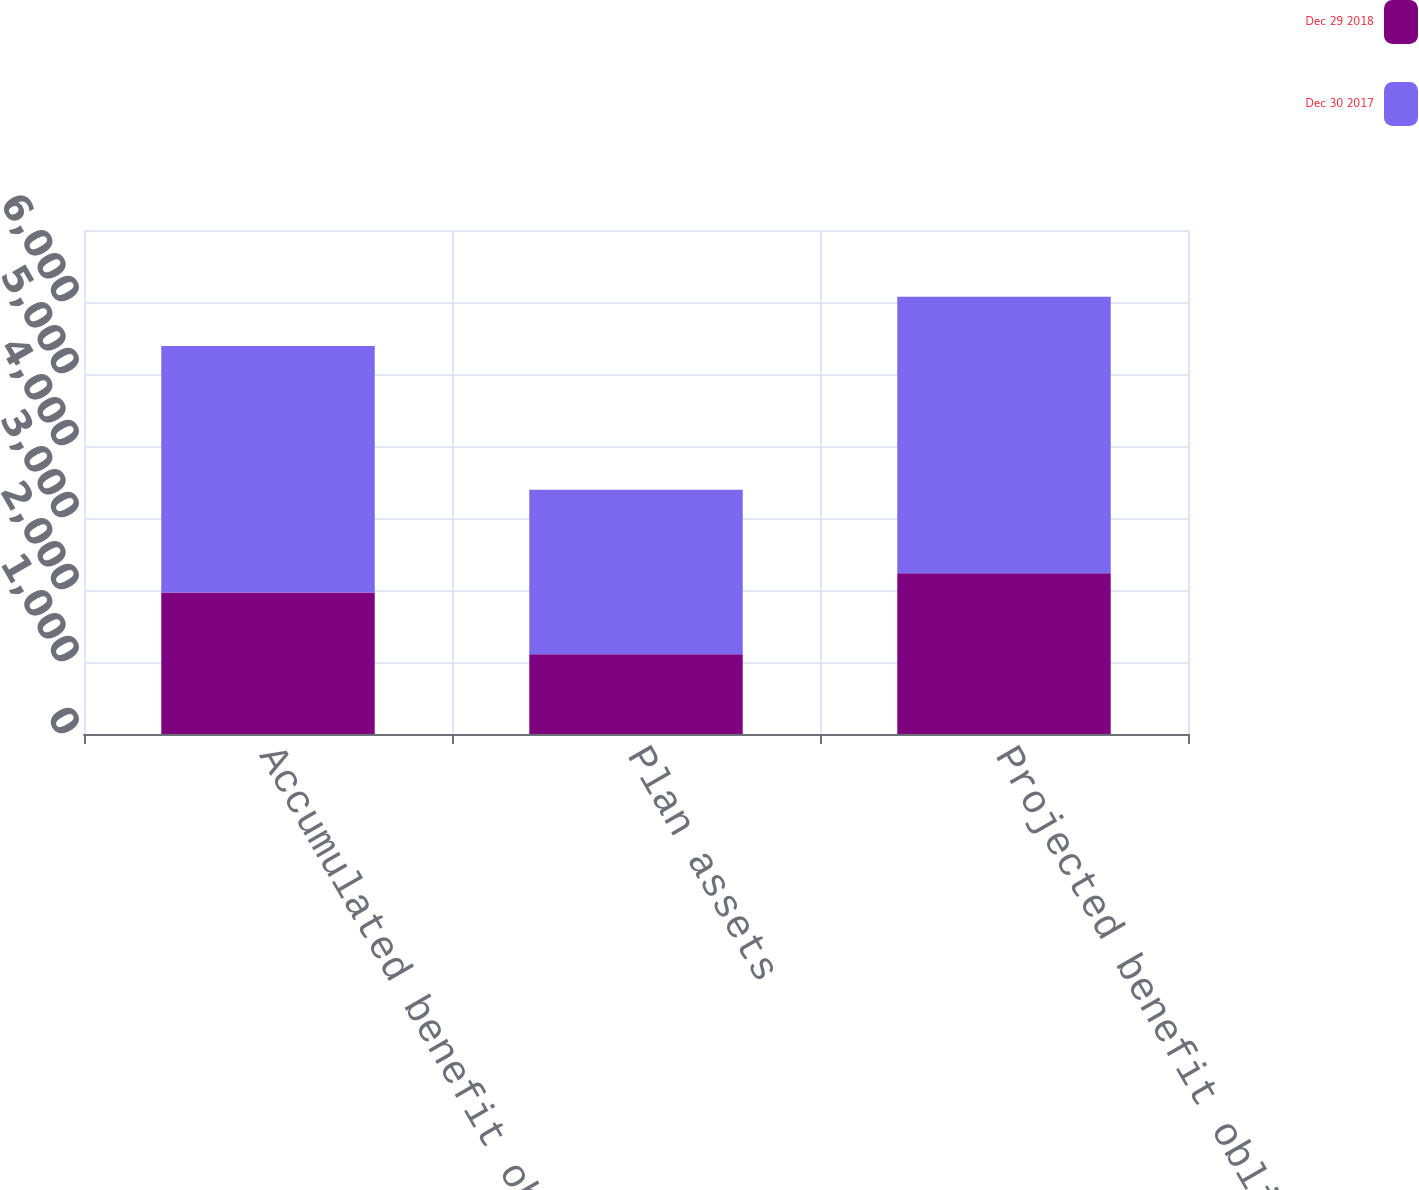<chart> <loc_0><loc_0><loc_500><loc_500><stacked_bar_chart><ecel><fcel>Accumulated benefit obligation<fcel>Plan assets<fcel>Projected benefit obligation<nl><fcel>Dec 29 2018<fcel>1965<fcel>1106<fcel>2232<nl><fcel>Dec 30 2017<fcel>3423<fcel>2287<fcel>3842<nl></chart> 